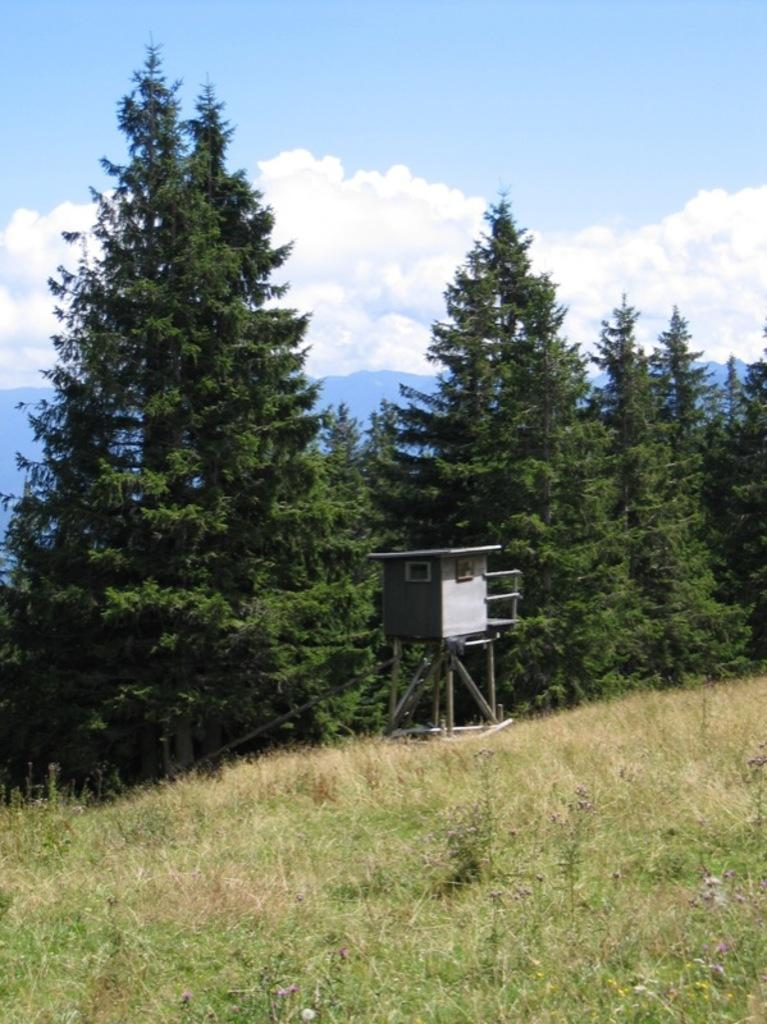What can be seen in the background of the image? The sky with clouds and trees are visible in the background of the image. What is the object placed near the trees? The fact does not specify the object, so we cannot answer this question definitively. What type of ground is present at the bottom of the image? Grass is present at the bottom of the image. Who is the owner of the dolls in the image? There are no dolls present in the image, so there is no owner to be identified. 